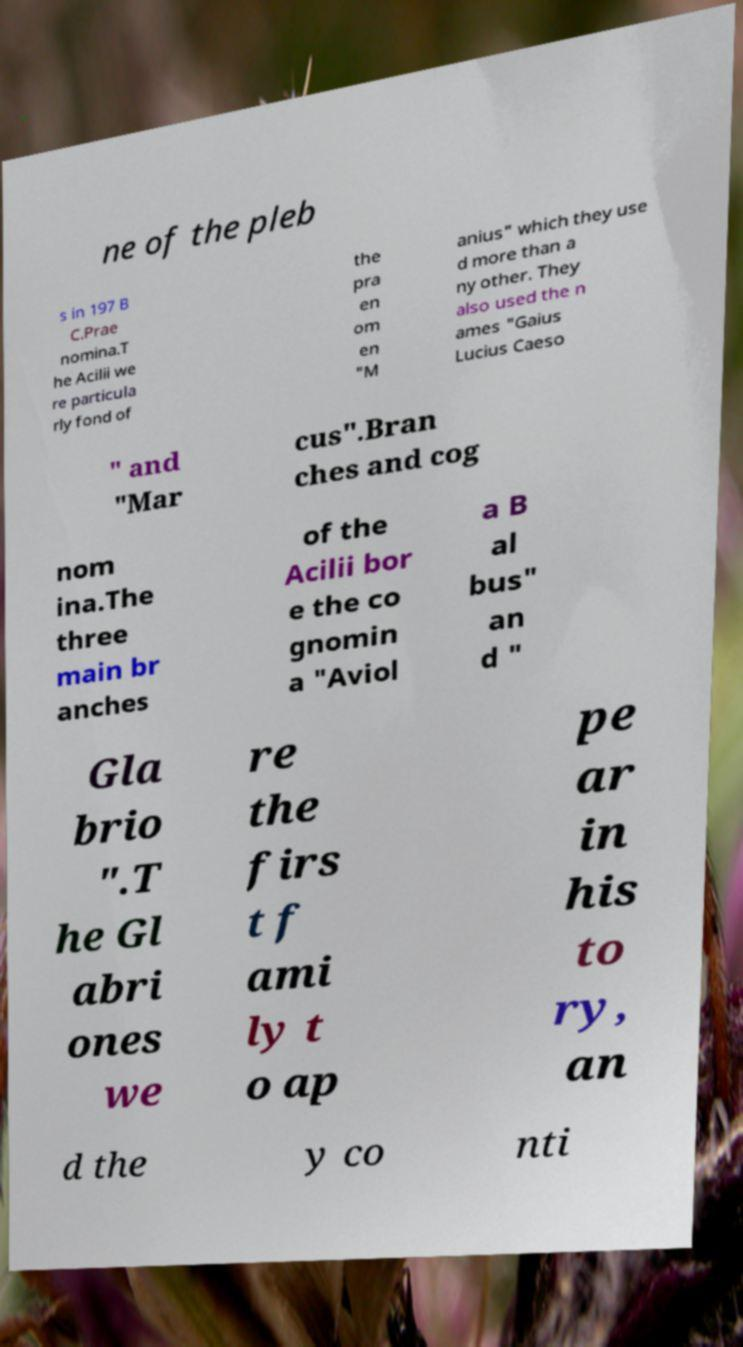Please read and relay the text visible in this image. What does it say? ne of the pleb s in 197 B C.Prae nomina.T he Acilii we re particula rly fond of the pra en om en "M anius" which they use d more than a ny other. They also used the n ames "Gaius Lucius Caeso " and "Mar cus".Bran ches and cog nom ina.The three main br anches of the Acilii bor e the co gnomin a "Aviol a B al bus" an d " Gla brio ".T he Gl abri ones we re the firs t f ami ly t o ap pe ar in his to ry, an d the y co nti 